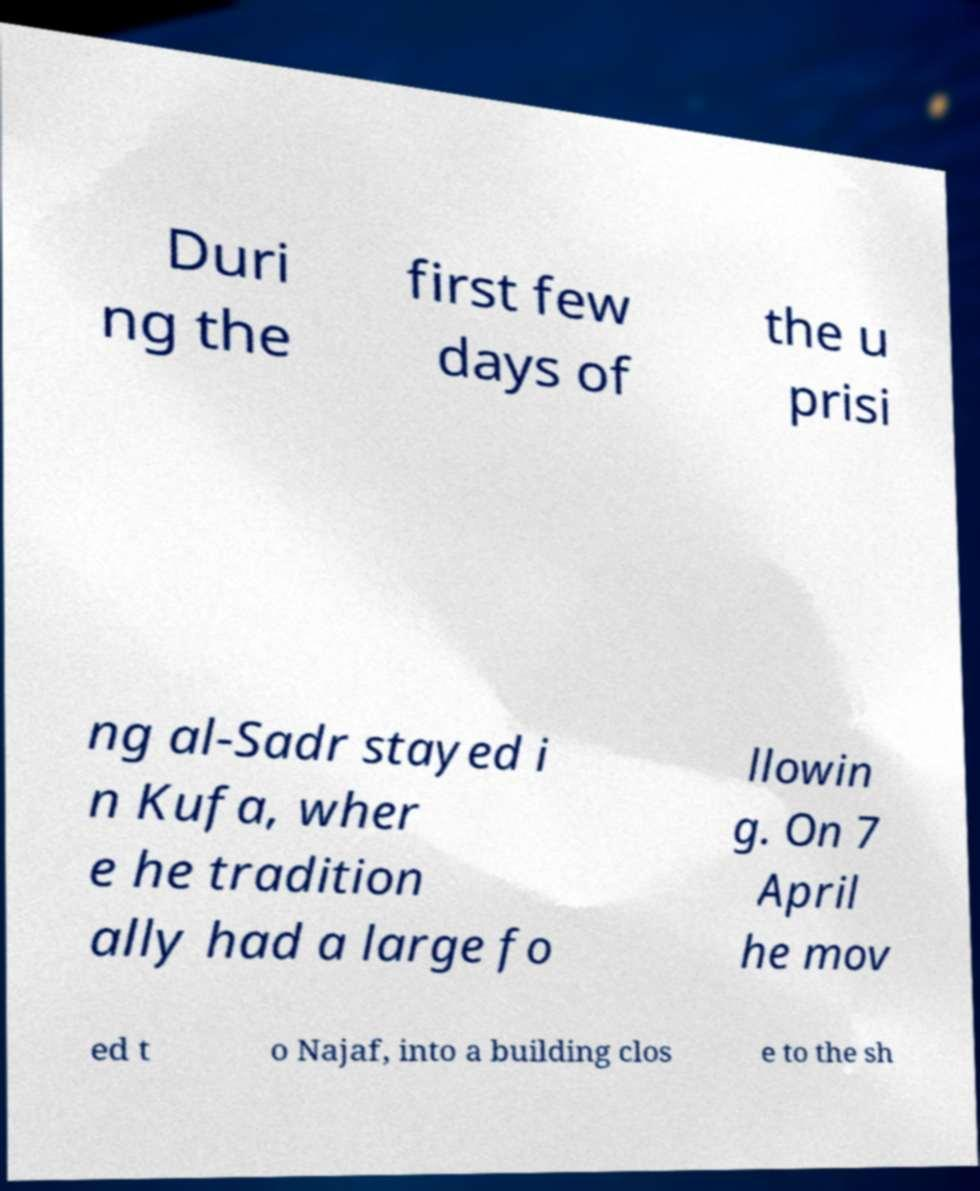Please identify and transcribe the text found in this image. Duri ng the first few days of the u prisi ng al-Sadr stayed i n Kufa, wher e he tradition ally had a large fo llowin g. On 7 April he mov ed t o Najaf, into a building clos e to the sh 